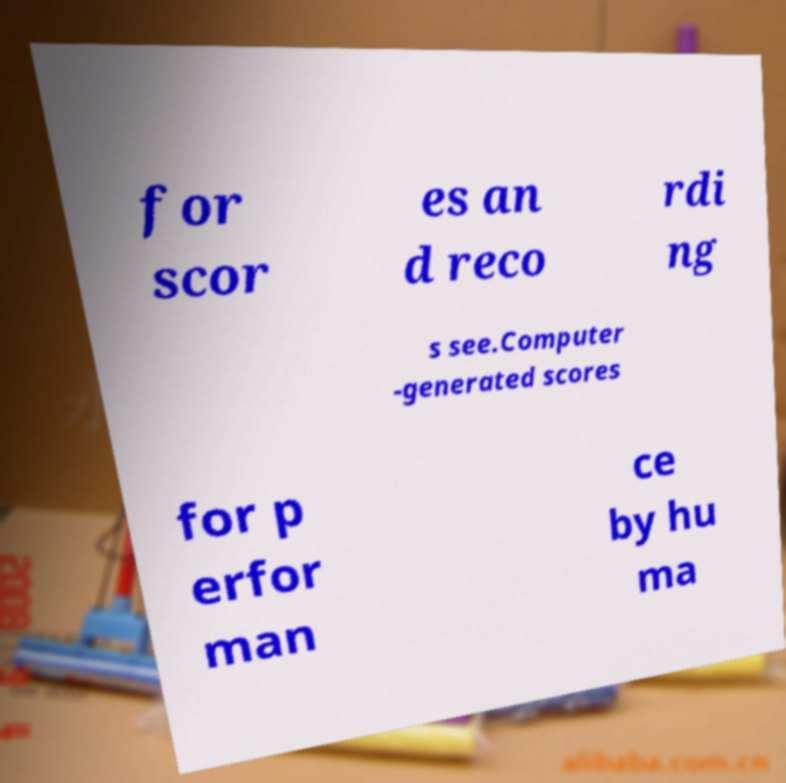For documentation purposes, I need the text within this image transcribed. Could you provide that? for scor es an d reco rdi ng s see.Computer -generated scores for p erfor man ce by hu ma 